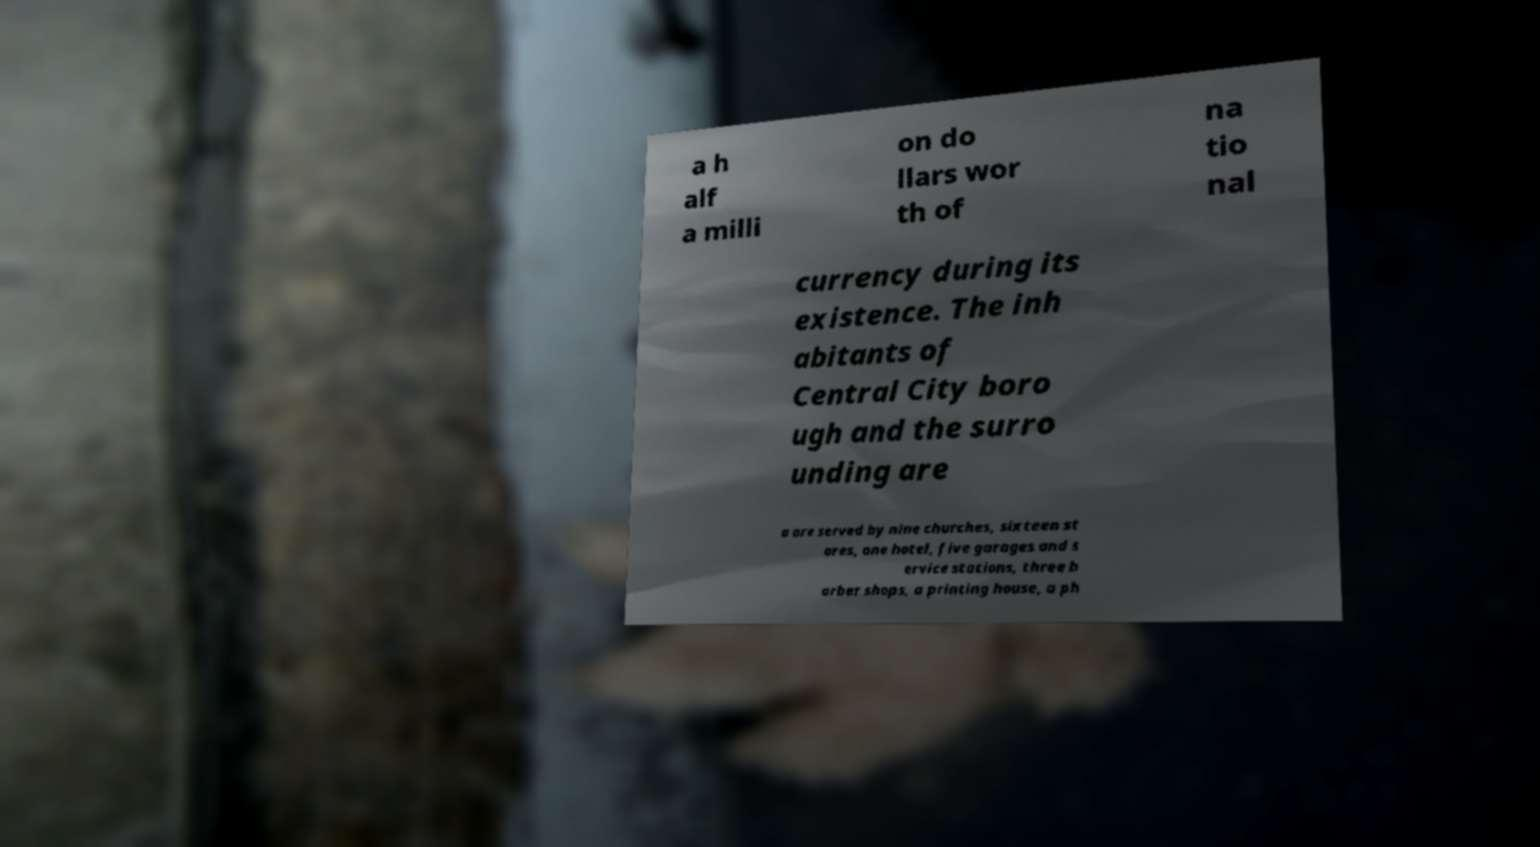There's text embedded in this image that I need extracted. Can you transcribe it verbatim? a h alf a milli on do llars wor th of na tio nal currency during its existence. The inh abitants of Central City boro ugh and the surro unding are a are served by nine churches, sixteen st ores, one hotel, five garages and s ervice stations, three b arber shops, a printing house, a ph 